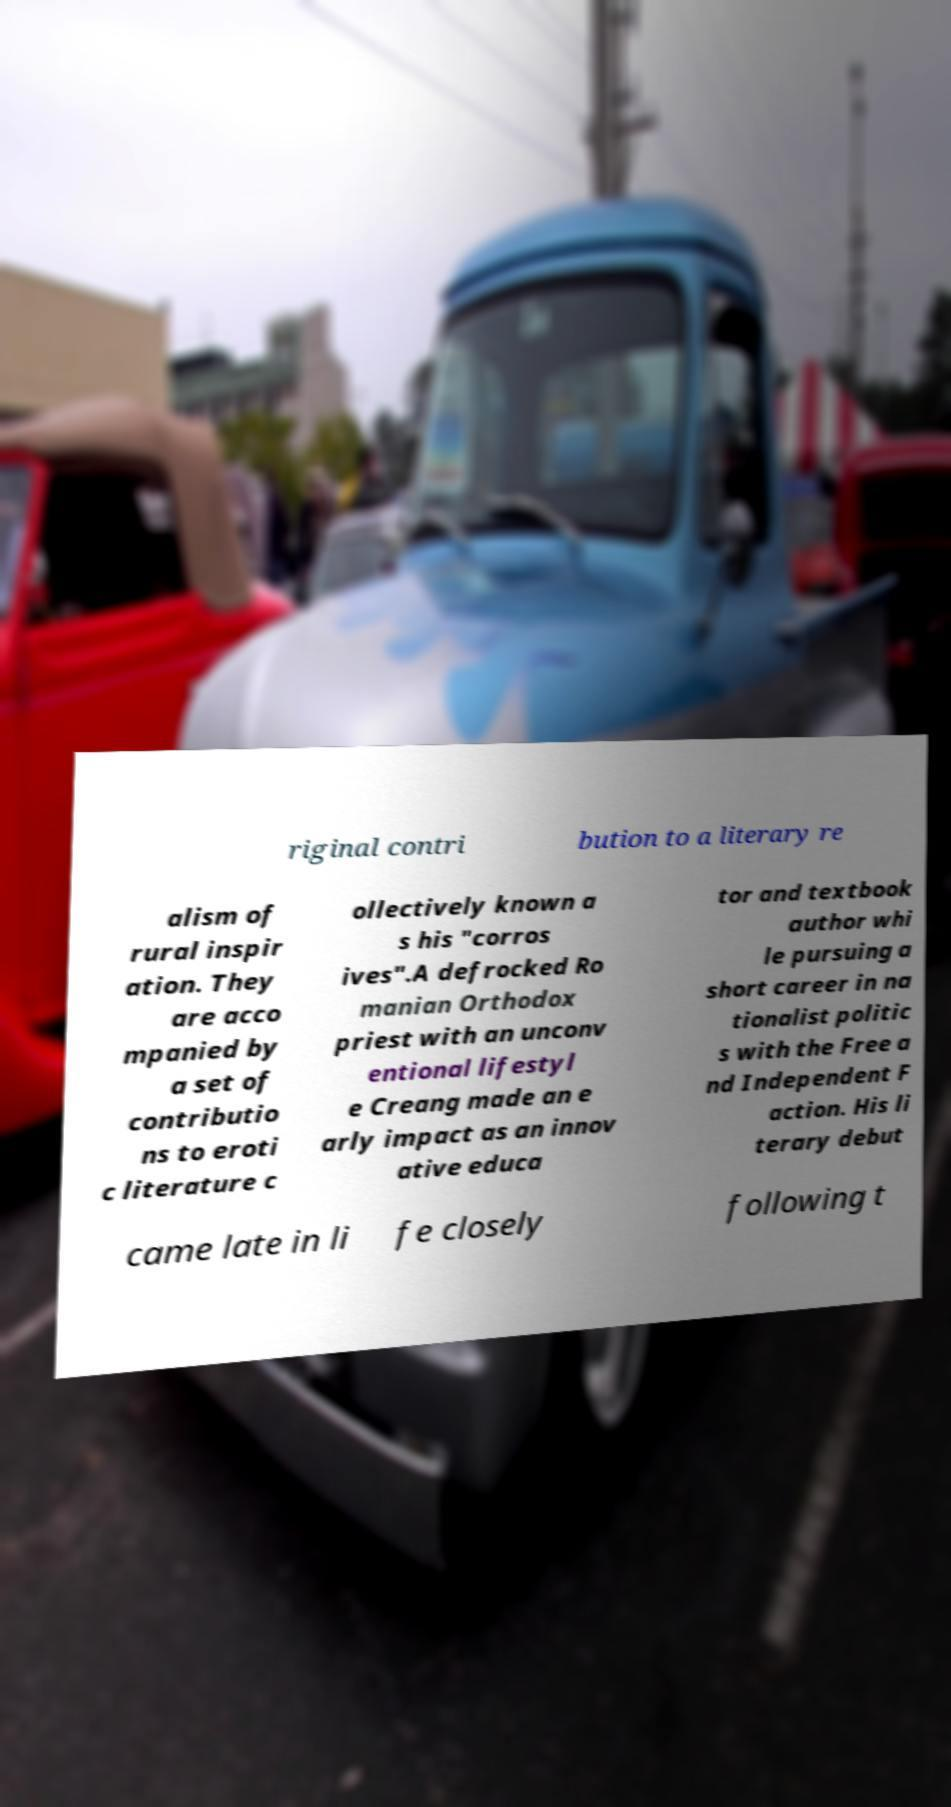Can you read and provide the text displayed in the image?This photo seems to have some interesting text. Can you extract and type it out for me? riginal contri bution to a literary re alism of rural inspir ation. They are acco mpanied by a set of contributio ns to eroti c literature c ollectively known a s his "corros ives".A defrocked Ro manian Orthodox priest with an unconv entional lifestyl e Creang made an e arly impact as an innov ative educa tor and textbook author whi le pursuing a short career in na tionalist politic s with the Free a nd Independent F action. His li terary debut came late in li fe closely following t 